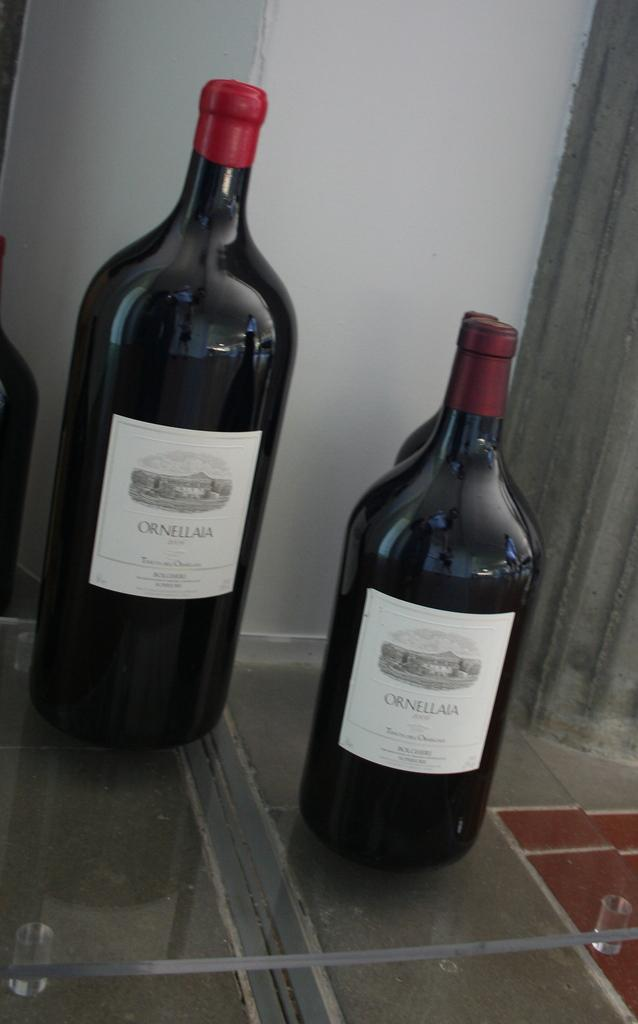<image>
Relay a brief, clear account of the picture shown. Two bottles have labels with the brand Ornellala on them. 